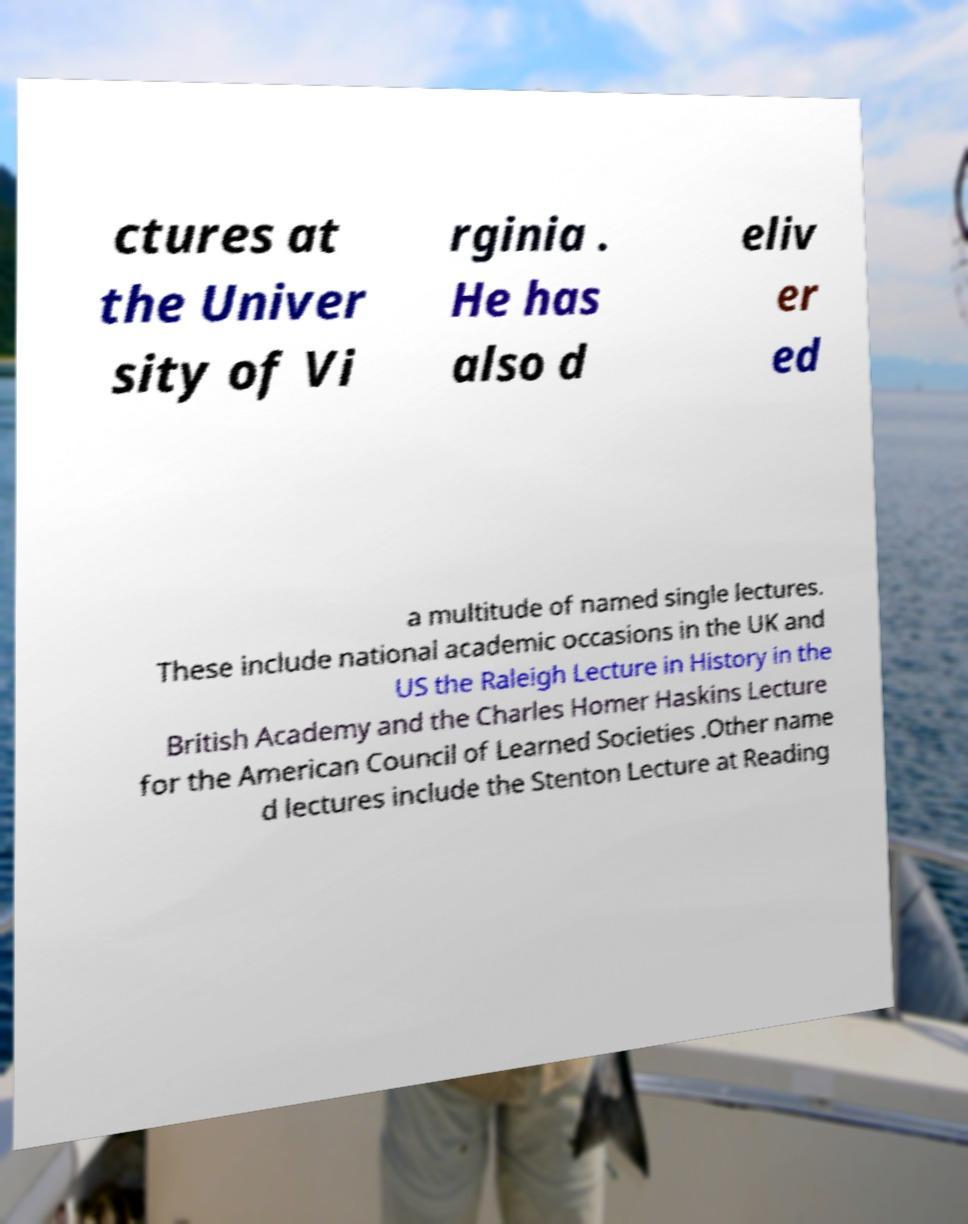Can you read and provide the text displayed in the image?This photo seems to have some interesting text. Can you extract and type it out for me? ctures at the Univer sity of Vi rginia . He has also d eliv er ed a multitude of named single lectures. These include national academic occasions in the UK and US the Raleigh Lecture in History in the British Academy and the Charles Homer Haskins Lecture for the American Council of Learned Societies .Other name d lectures include the Stenton Lecture at Reading 